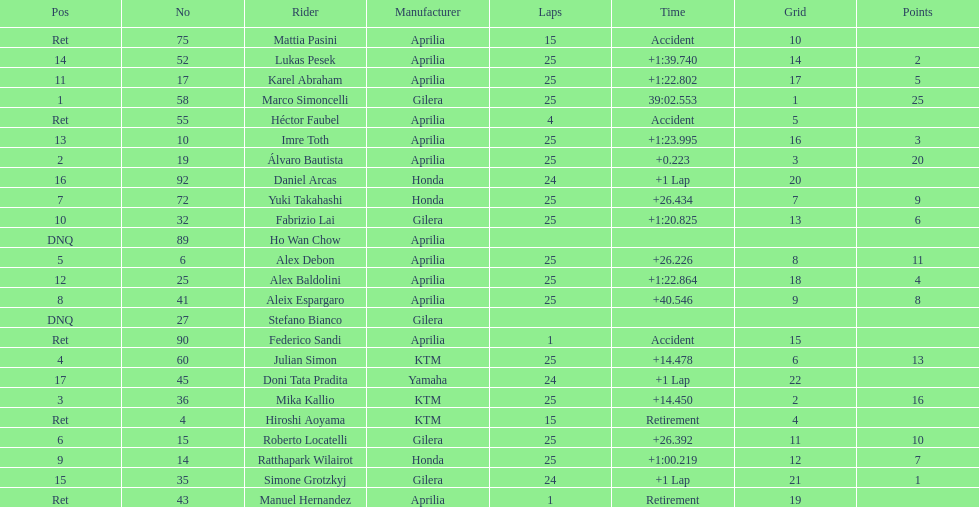Who is marco simoncelli's manufacturer Gilera. 